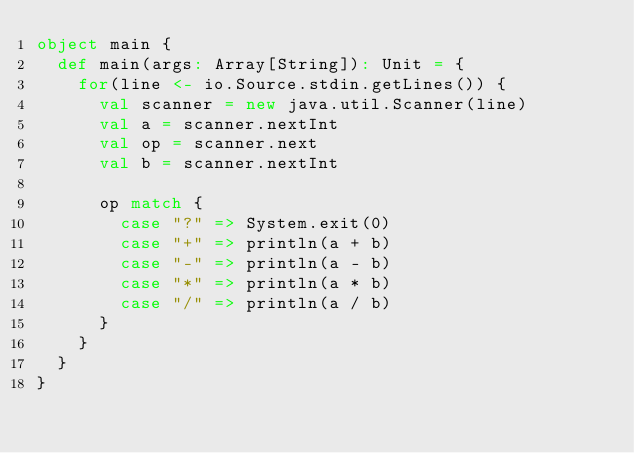Convert code to text. <code><loc_0><loc_0><loc_500><loc_500><_Scala_>object main {
  def main(args: Array[String]): Unit = {
    for(line <- io.Source.stdin.getLines()) {
      val scanner = new java.util.Scanner(line)
      val a = scanner.nextInt
      val op = scanner.next
      val b = scanner.nextInt

      op match {
        case "?" => System.exit(0)
        case "+" => println(a + b)
        case "-" => println(a - b)
        case "*" => println(a * b)
        case "/" => println(a / b)
      }
    }
  }
}
</code> 